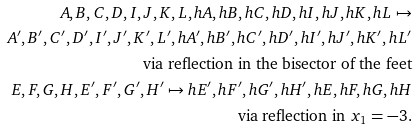<formula> <loc_0><loc_0><loc_500><loc_500>A , B , C , D , I , J , K , L , h A , h B , h C , h D , h I , h J , h K , h L \mapsto \\ A ^ { \prime } , B ^ { \prime } , C ^ { \prime } , D ^ { \prime } , I ^ { \prime } , J ^ { \prime } , K ^ { \prime } , L ^ { \prime } , h A ^ { \prime } , h B ^ { \prime } , h C ^ { \prime } , h D ^ { \prime } , h I ^ { \prime } , h J ^ { \prime } , h K ^ { \prime } , h L ^ { \prime } \\ \text {via reflection in the bisector of the feet} \\ E , F , G , H , E ^ { \prime } , F ^ { \prime } , G ^ { \prime } , H ^ { \prime } \mapsto h E ^ { \prime } , h F ^ { \prime } , h G ^ { \prime } , h H ^ { \prime } , h E , h F , h G , h H \\ \text {via reflection in $x_{1}=-3$.}</formula> 